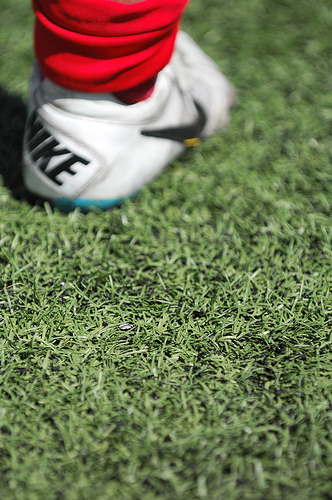<image>
Is there a sneaker above the grass? No. The sneaker is not positioned above the grass. The vertical arrangement shows a different relationship. Is there a shoe to the left of the grass? Yes. From this viewpoint, the shoe is positioned to the left side relative to the grass. 